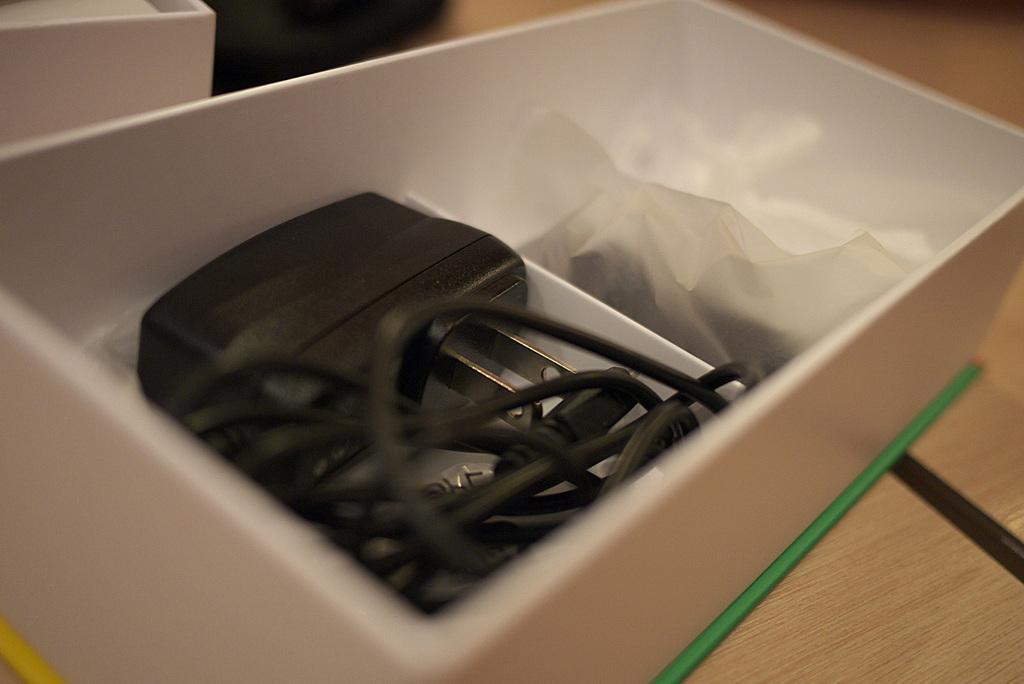How would you summarize this image in a sentence or two? In this image, we can see the device and cover in the white box. On the right side bottom corner, there is a wooden surface and black color. Top of the image, there is a blur view. On the left side top corner, there is a white color object. 